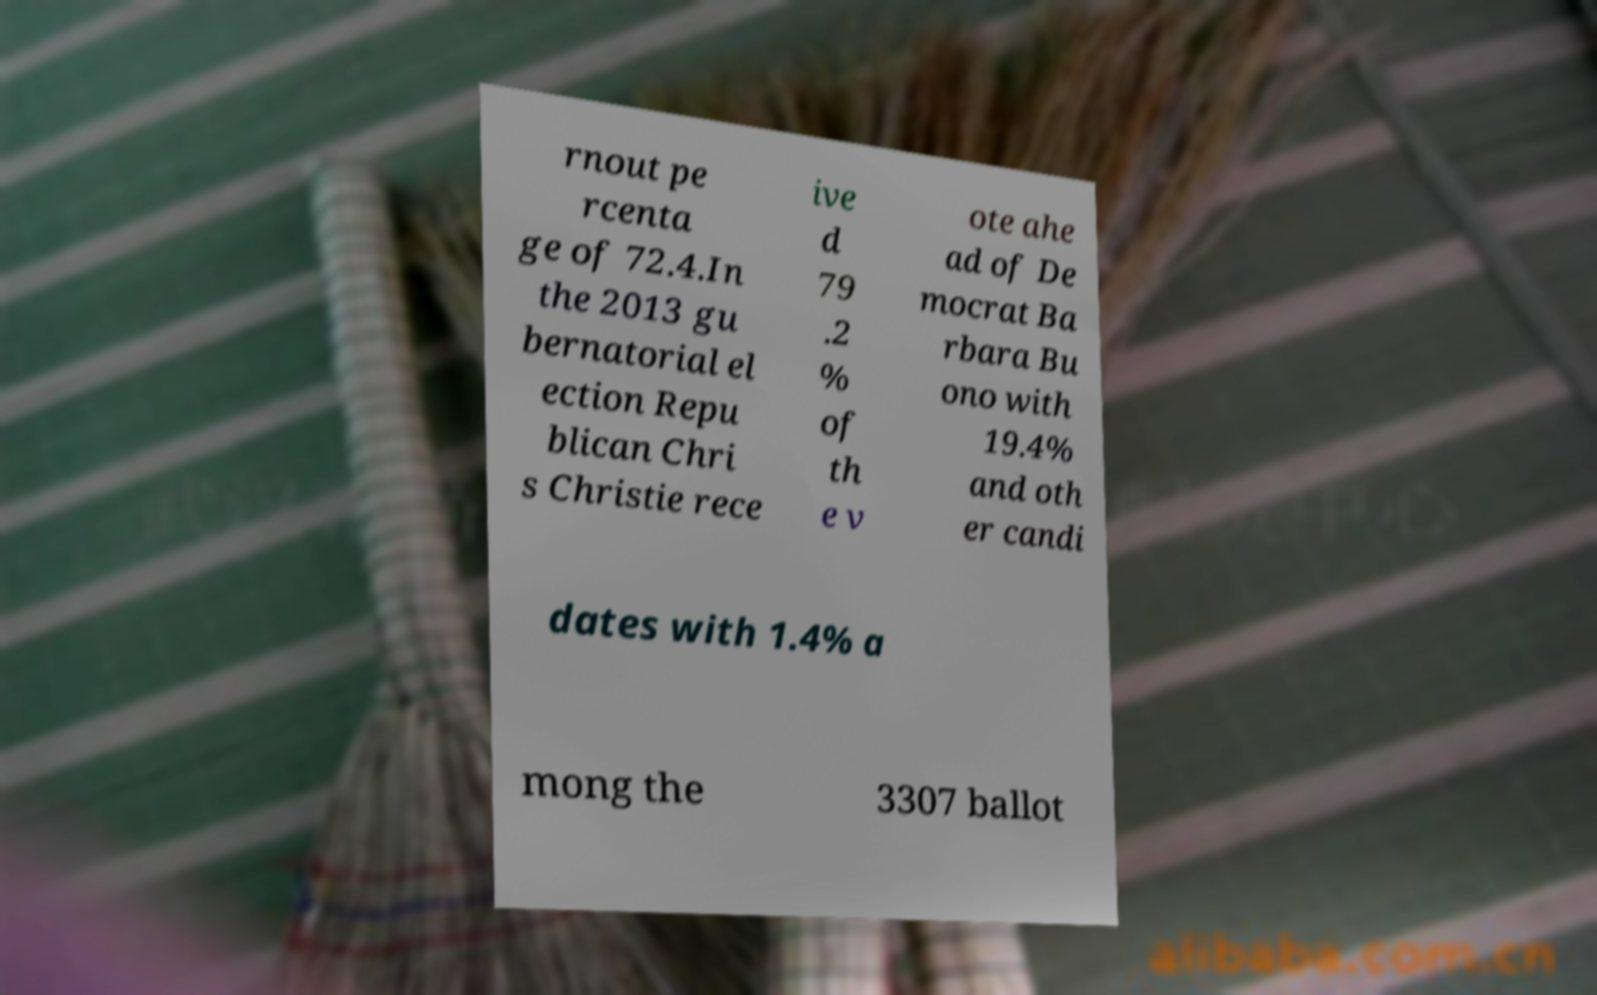What messages or text are displayed in this image? I need them in a readable, typed format. rnout pe rcenta ge of 72.4.In the 2013 gu bernatorial el ection Repu blican Chri s Christie rece ive d 79 .2 % of th e v ote ahe ad of De mocrat Ba rbara Bu ono with 19.4% and oth er candi dates with 1.4% a mong the 3307 ballot 